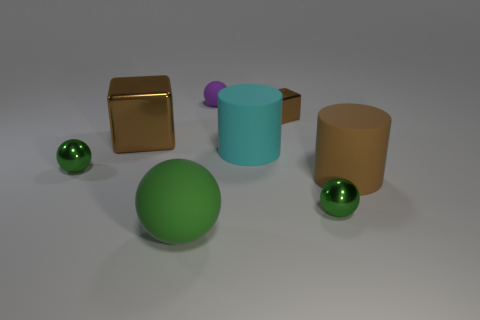How do the textures of the objects compare? The objects present a variety of textures. The green cylinder and the large brown cylinder possess a smooth, matte finish, while the metal cube reflects light, indicating a glossy metallic surface. The spheres mirror the same textural duality; the large green sphere has a matte finish similar to its adjacent cylinder, while the smaller spheres exhibit a polished gleam, indicative of a reflective material. 